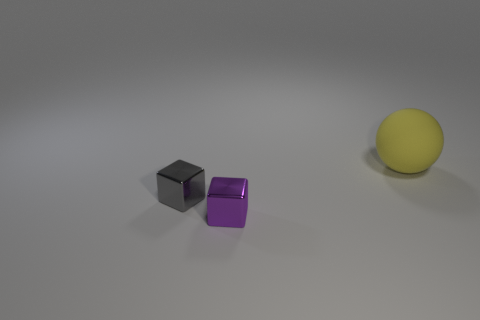Do the large yellow sphere and the purple cube have the same material?
Provide a succinct answer. No. Is there anything else that has the same material as the big object?
Keep it short and to the point. No. Does the yellow sphere have the same material as the small thing behind the small purple object?
Your response must be concise. No. What material is the small thing behind the purple metallic object?
Provide a short and direct response. Metal. What is the material of the thing that is the same size as the gray cube?
Ensure brevity in your answer.  Metal. How many metallic objects are either small gray cubes or big spheres?
Your answer should be very brief. 1. The small gray metal object has what shape?
Your answer should be very brief. Cube. How many gray things are the same material as the small purple block?
Make the answer very short. 1. The other object that is made of the same material as the gray thing is what color?
Provide a succinct answer. Purple. There is a shiny cube behind the purple thing; is its size the same as the tiny purple shiny block?
Your response must be concise. Yes. 